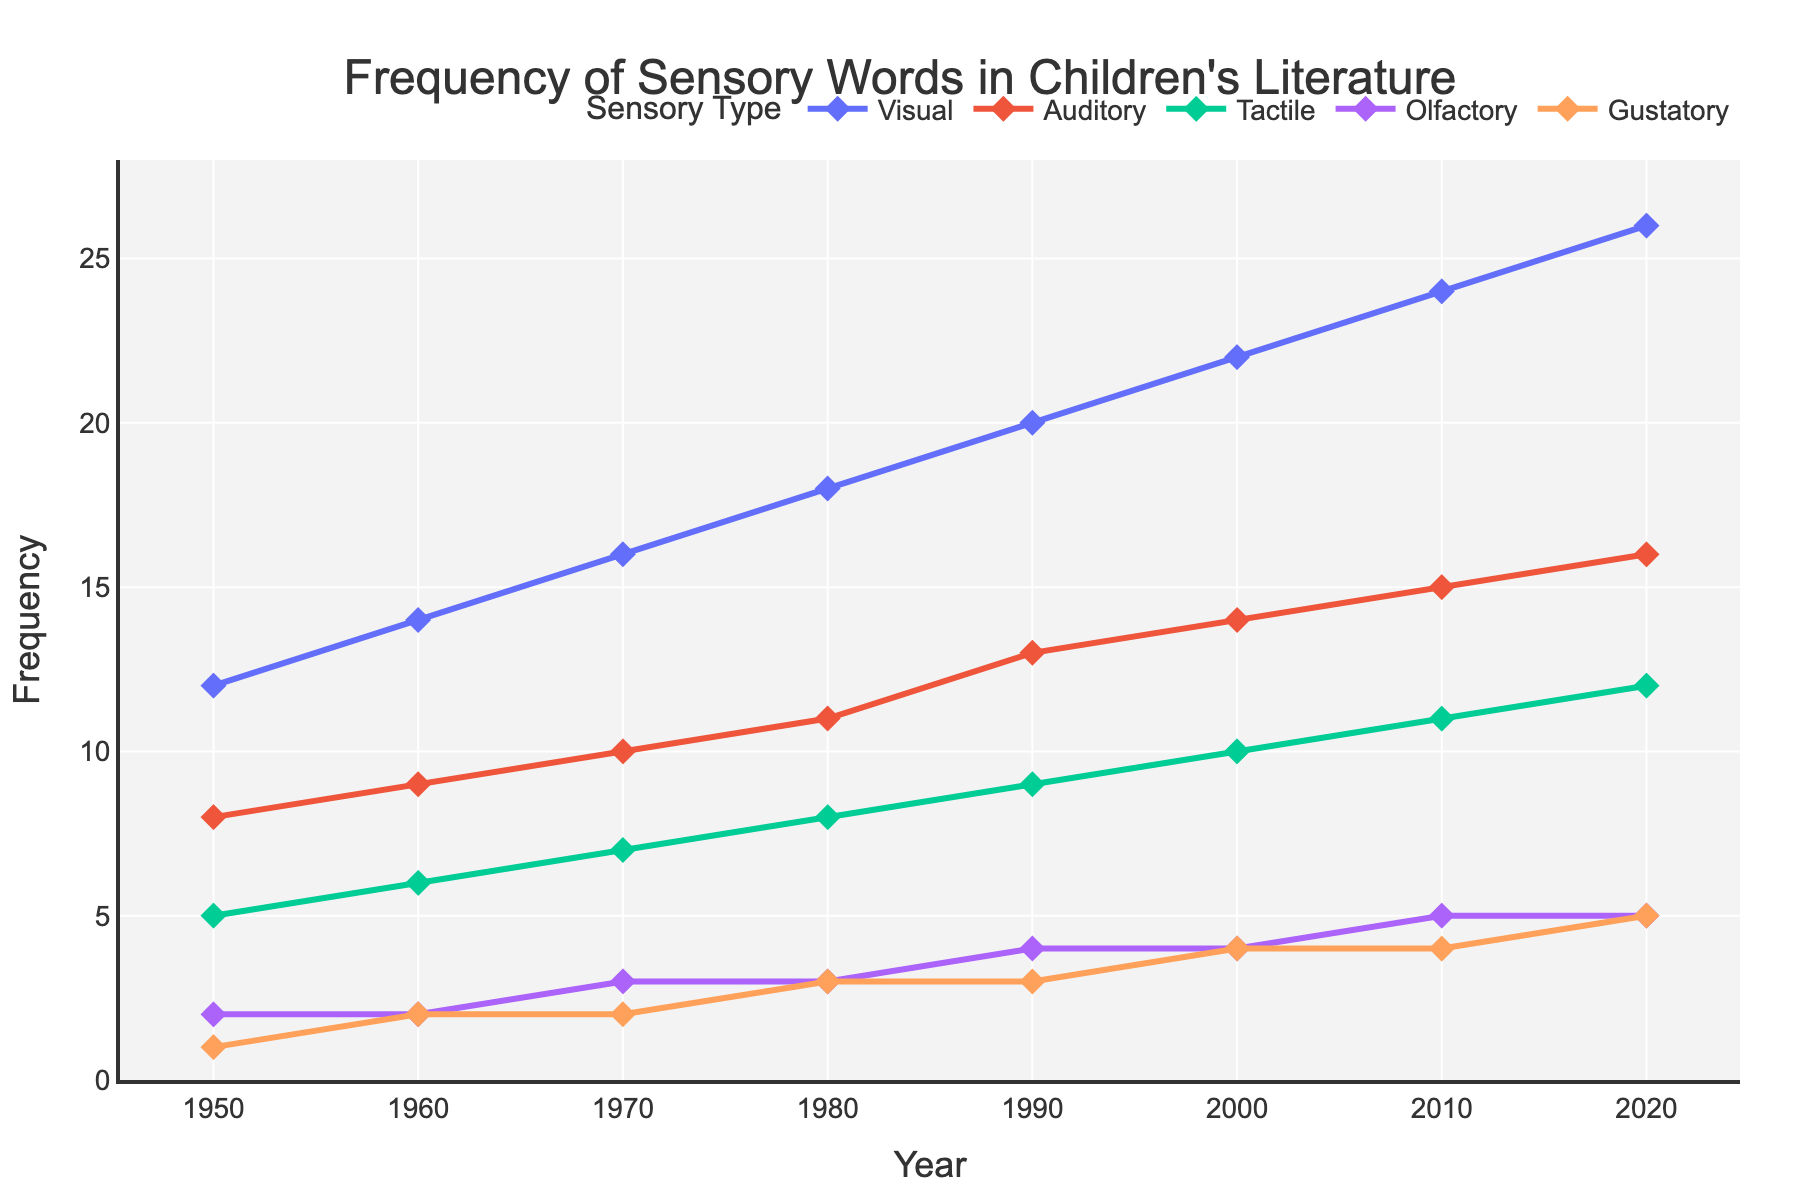What sensory word had the highest frequency in 2020? To find the sensory word with the highest frequency in 2020, look at the data points on the chart for the year 2020 and compare each sensory word. The highest value is for Visual, which is 26.
Answer: Visual How much did the frequency of visual sensory words increase from 1950 to 2020? To calculate the increase, subtract the frequency in 1950 from the frequency in 2020. For Visual, it's 26 (in 2020) - 12 (in 1950) = 14.
Answer: 14 Which sensory word had the smallest growth in frequency from 1950 to 2020? Compare the difference in frequency for each sensory word between 1950 and 2020. The smallest growth is for Olfactory, with an increase of 3 (5 in 2020 - 2 in 1950).
Answer: Olfactory Is the frequency of tactile sensory words in 2000 greater than the frequency of auditory sensory words in 1960? Compare the value for Tactile in 2000 (10) with Auditory in 1960 (9). Since 10 is greater than 9, the answer is yes.
Answer: Yes What is the average frequency of gustatory sensory words from 1950 to 2020? Add the frequencies for Gustatory from each decade and divide by the number of decades: (1+2+2+3+3+4+4+5) / 8 = 24 / 8 = 3.
Answer: 3 Between 1970 and 2020, which sensory word had the most consistent linear growth? Assess the trends of each sensory word from 1970 to 2020. Visual words grew steadily by about 2 every decade (16, 18, 20, 22, 24, 26), indicating the most consistent linear growth.
Answer: Visual How many more visual sensory words were there compared to olfactory sensory words in 2010? Subtract the number of Olfactory words from Visual words in 2010: 24 (Visual) - 5 (Olfactory) = 19.
Answer: 19 Which sensory word showed equal frequency growth between 1980 to 1990 and 1990 to 2000? Visualize the growth for each word and find equal increments. Tactile increased by 1 from 1980 to 1990 (8 to 9), and again by 1 from 1990 to 2000 (9 to 10).
Answer: Tactile Which decade saw the highest growth in the frequency of visual sensory words? Calculate the growth for Visual sensory words for each decade and compare them. The largest growth is 4, occurring from 1990 to 2000 and from 2000 to 2010.
Answer: 1990-2000 and 2000-2010 Compared to 1980, how much more frequent were auditory sensory words in 2020? Subtract the frequency of Auditory sensory words in 1980 from that in 2020: 16 (in 2020) - 11 (in 1980) = 5.
Answer: 5 